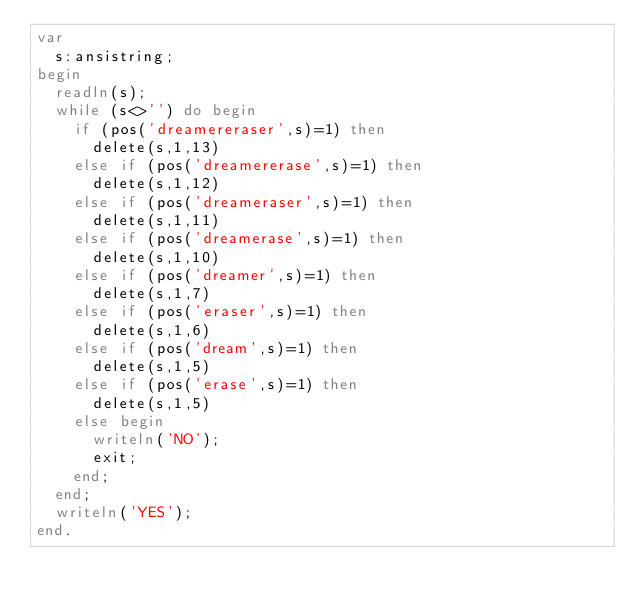<code> <loc_0><loc_0><loc_500><loc_500><_Pascal_>var
  s:ansistring;
begin
  readln(s);
  while (s<>'') do begin
    if (pos('dreamereraser',s)=1) then
      delete(s,1,13)
    else if (pos('dreamererase',s)=1) then
      delete(s,1,12)
    else if (pos('dreameraser',s)=1) then 
      delete(s,1,11)
    else if (pos('dreamerase',s)=1) then
      delete(s,1,10)
    else if (pos('dreamer',s)=1) then
      delete(s,1,7)
    else if (pos('eraser',s)=1) then
      delete(s,1,6)
    else if (pos('dream',s)=1) then
      delete(s,1,5)
    else if (pos('erase',s)=1) then
      delete(s,1,5)
    else begin
      writeln('NO');
      exit;
    end;
  end;
  writeln('YES');
end.
  
</code> 